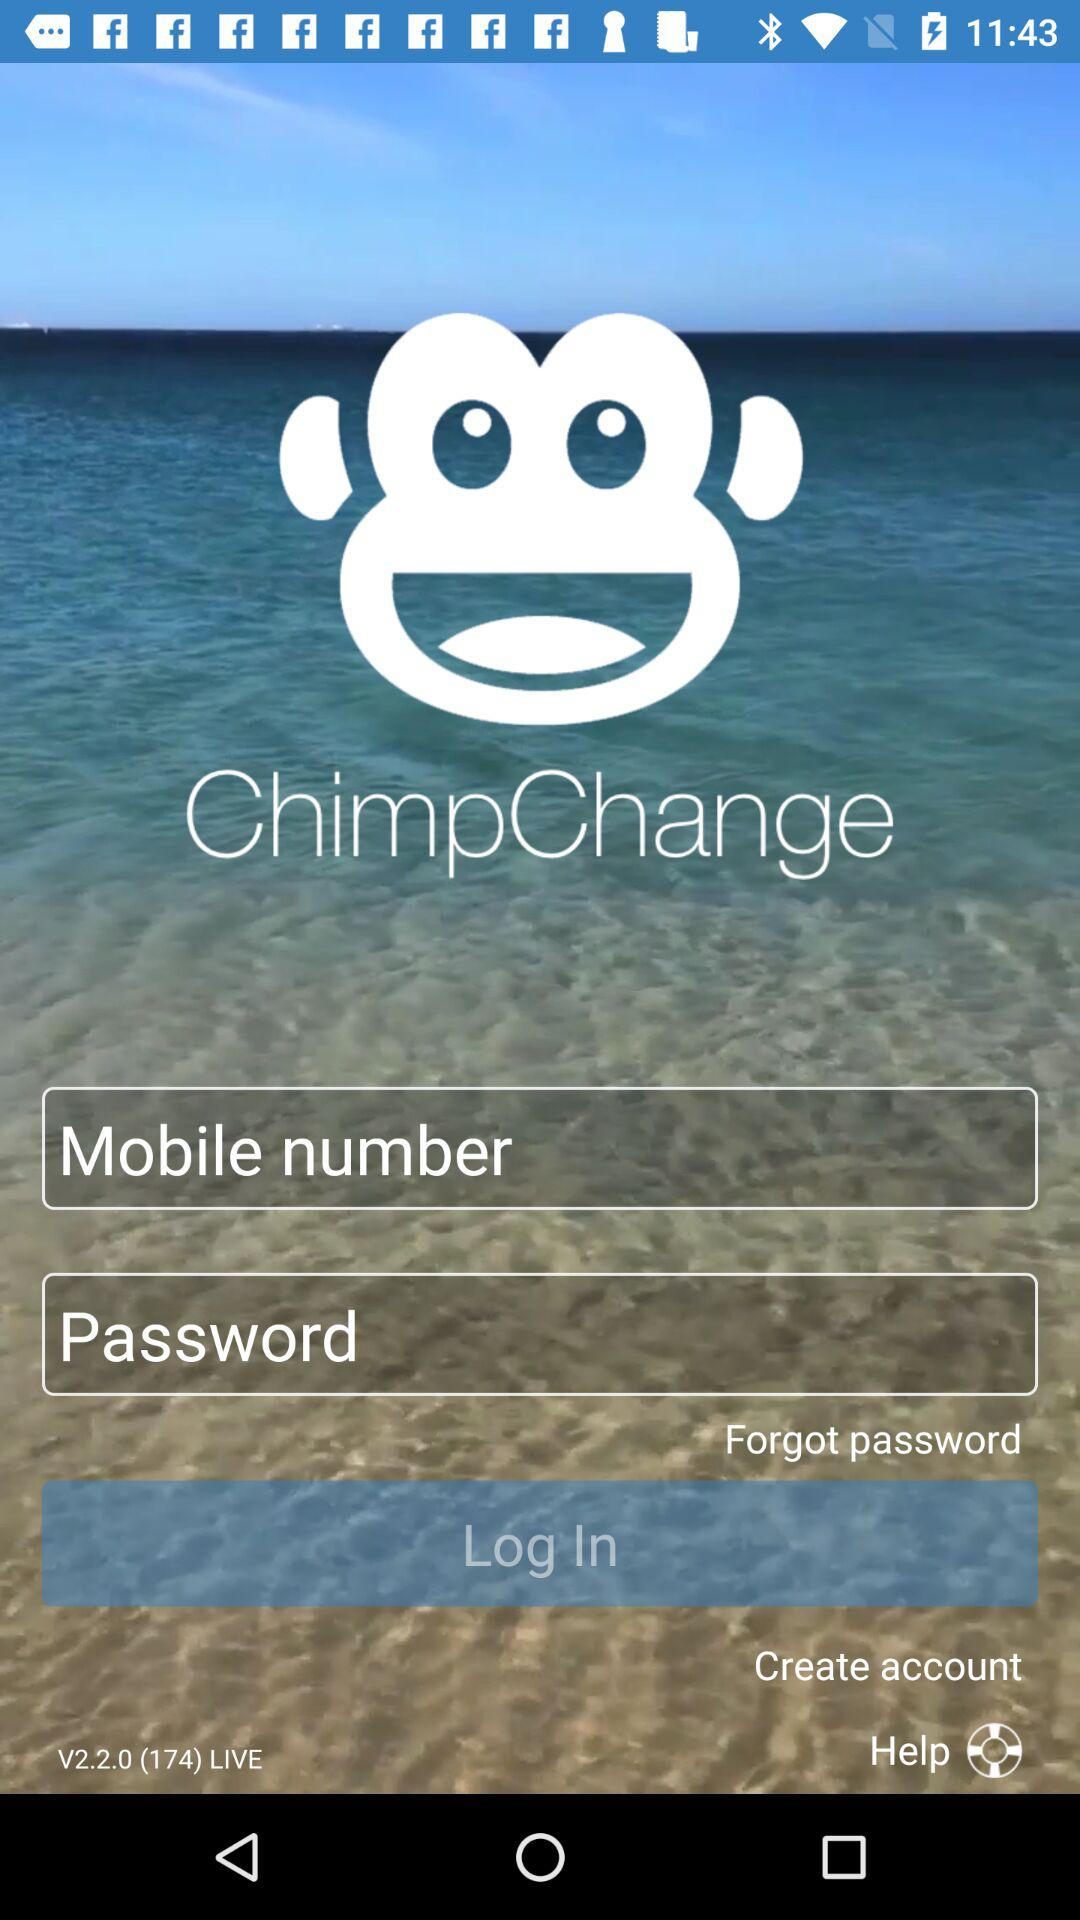What are the requirements to login? The requirements to login are a mobile number and a password. 